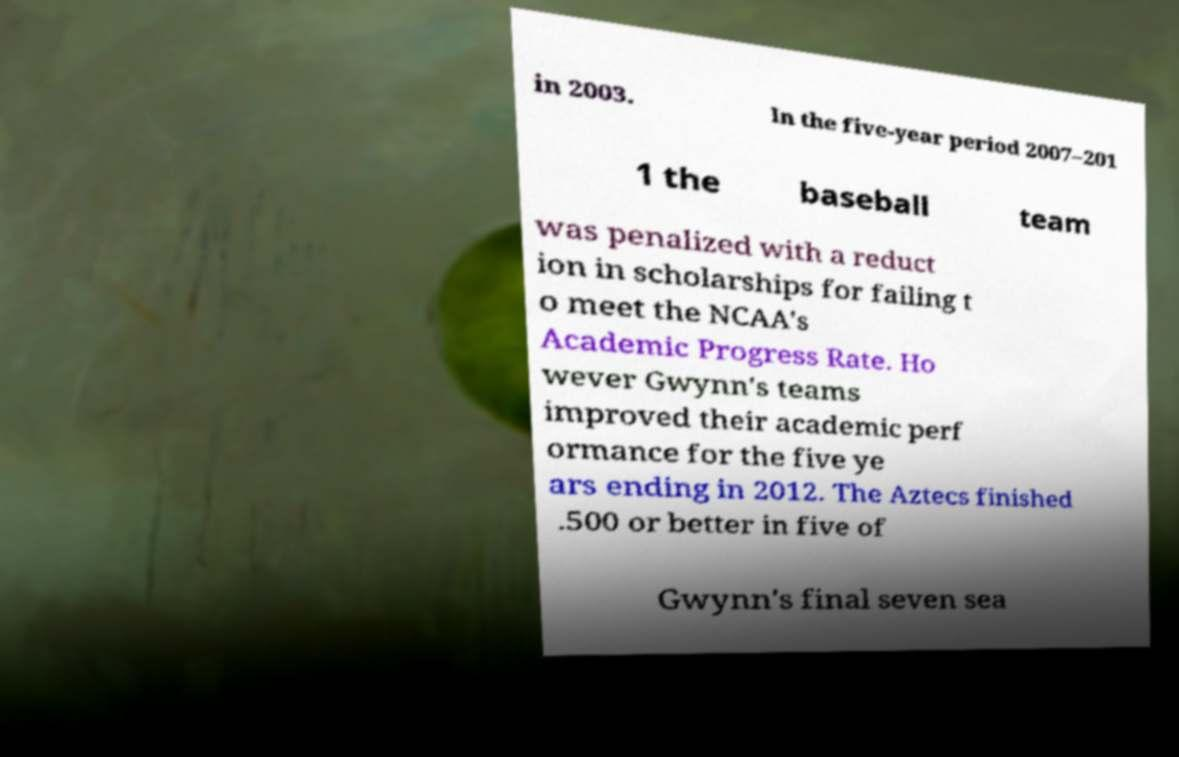Could you assist in decoding the text presented in this image and type it out clearly? in 2003. In the five-year period 2007–201 1 the baseball team was penalized with a reduct ion in scholarships for failing t o meet the NCAA's Academic Progress Rate. Ho wever Gwynn's teams improved their academic perf ormance for the five ye ars ending in 2012. The Aztecs finished .500 or better in five of Gwynn's final seven sea 